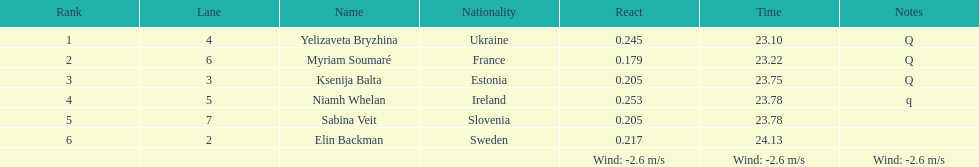Are any of the lanes in successive order? No. 